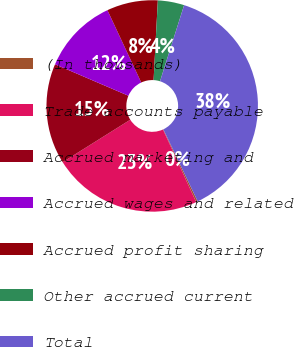<chart> <loc_0><loc_0><loc_500><loc_500><pie_chart><fcel>(In thousands)<fcel>Trade accounts payable<fcel>Accrued marketing and<fcel>Accrued wages and related<fcel>Accrued profit sharing<fcel>Other accrued current<fcel>Total<nl><fcel>0.25%<fcel>22.91%<fcel>15.37%<fcel>11.59%<fcel>7.81%<fcel>4.03%<fcel>38.05%<nl></chart> 